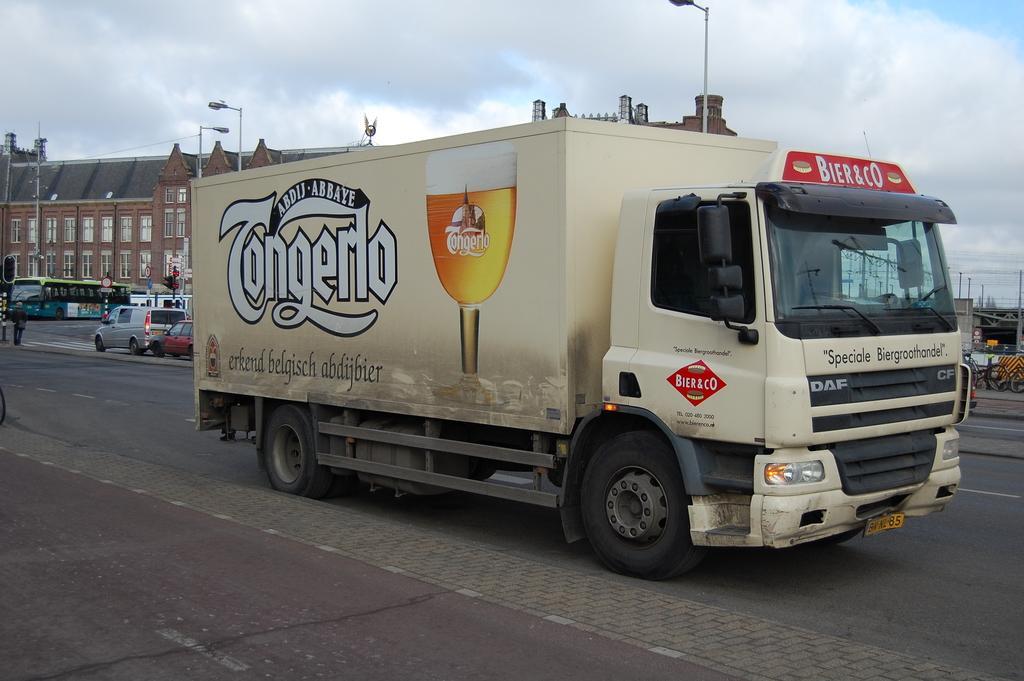In one or two sentences, can you explain what this image depicts? There is a truck on the road and there are few vehicles behind it and there is a building in the background. 